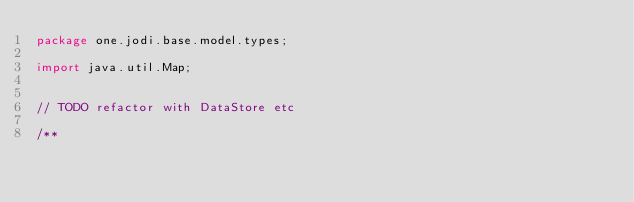<code> <loc_0><loc_0><loc_500><loc_500><_Java_>package one.jodi.base.model.types;

import java.util.Map;


// TODO refactor with DataStore etc 

/**</code> 